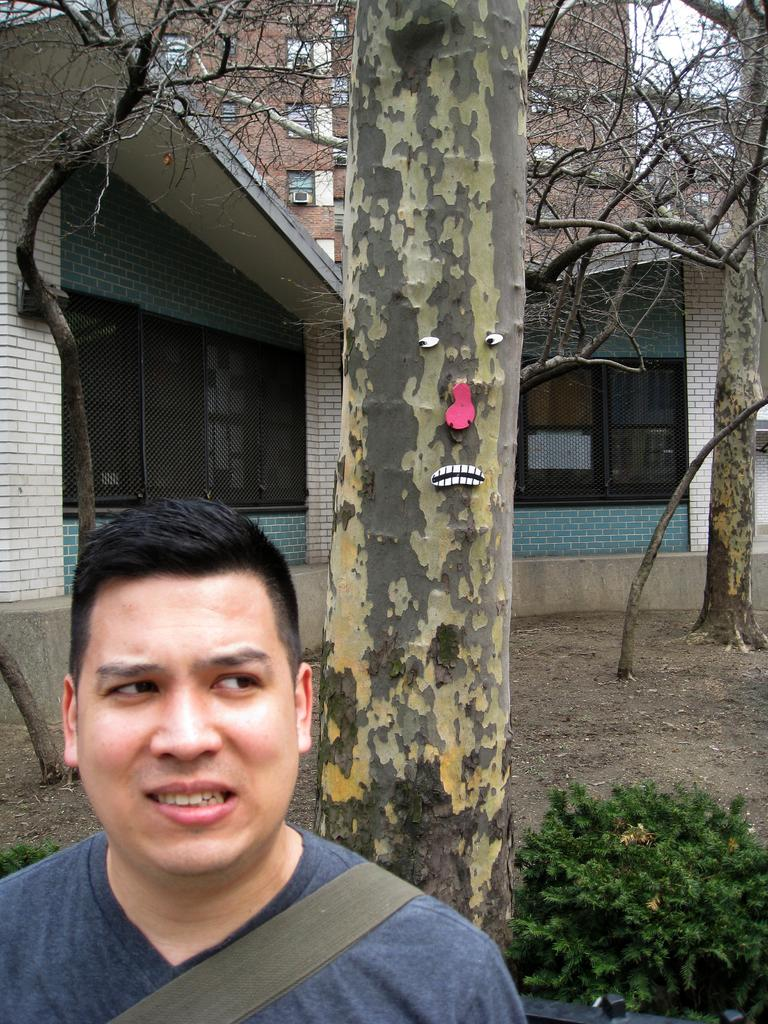What is the person in the image wearing? There is a person wearing a dress in the image. What is located in the center of the image? There is a tree in the center of the image. What can be seen in the background of the image? There are buildings with windows and a group of trees in the background of the image. What is visible in the sky in the image? The sky is visible in the background of the image. What type of jeans is the person wearing in the image? The person in the image is not wearing jeans; they are wearing a dress. How does the group of trees move in the image? The group of trees does not move in the image; they are stationary. 